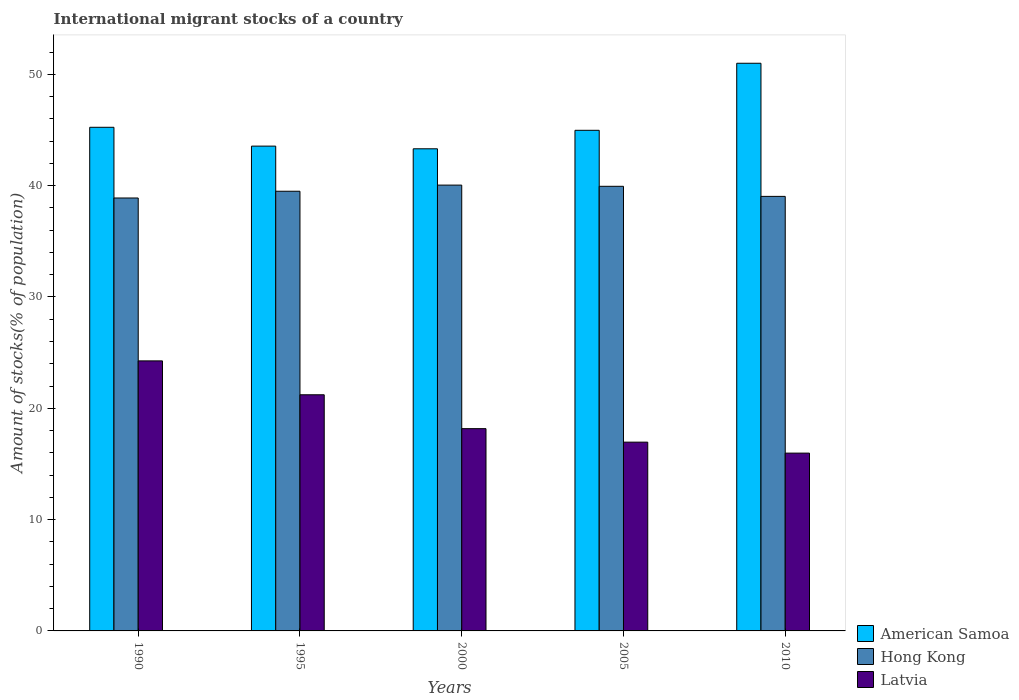How many groups of bars are there?
Provide a succinct answer. 5. Are the number of bars on each tick of the X-axis equal?
Your response must be concise. Yes. How many bars are there on the 1st tick from the left?
Your answer should be very brief. 3. What is the label of the 4th group of bars from the left?
Provide a succinct answer. 2005. In how many cases, is the number of bars for a given year not equal to the number of legend labels?
Offer a very short reply. 0. What is the amount of stocks in in American Samoa in 2000?
Offer a very short reply. 43.31. Across all years, what is the maximum amount of stocks in in Hong Kong?
Give a very brief answer. 40.05. Across all years, what is the minimum amount of stocks in in Latvia?
Provide a succinct answer. 15.97. In which year was the amount of stocks in in American Samoa maximum?
Keep it short and to the point. 2010. What is the total amount of stocks in in Hong Kong in the graph?
Your answer should be very brief. 197.41. What is the difference between the amount of stocks in in American Samoa in 1990 and that in 2010?
Keep it short and to the point. -5.75. What is the difference between the amount of stocks in in Latvia in 2010 and the amount of stocks in in Hong Kong in 1995?
Your answer should be very brief. -23.52. What is the average amount of stocks in in Latvia per year?
Give a very brief answer. 19.31. In the year 1995, what is the difference between the amount of stocks in in Hong Kong and amount of stocks in in Latvia?
Your answer should be compact. 18.28. In how many years, is the amount of stocks in in Latvia greater than 44 %?
Provide a succinct answer. 0. What is the ratio of the amount of stocks in in Hong Kong in 1995 to that in 2005?
Ensure brevity in your answer.  0.99. Is the amount of stocks in in Hong Kong in 2000 less than that in 2010?
Give a very brief answer. No. Is the difference between the amount of stocks in in Hong Kong in 1990 and 2010 greater than the difference between the amount of stocks in in Latvia in 1990 and 2010?
Provide a short and direct response. No. What is the difference between the highest and the second highest amount of stocks in in Latvia?
Make the answer very short. 3.04. What is the difference between the highest and the lowest amount of stocks in in American Samoa?
Keep it short and to the point. 7.68. What does the 2nd bar from the left in 1995 represents?
Give a very brief answer. Hong Kong. What does the 1st bar from the right in 2000 represents?
Provide a succinct answer. Latvia. Are all the bars in the graph horizontal?
Your answer should be very brief. No. How many years are there in the graph?
Provide a succinct answer. 5. What is the difference between two consecutive major ticks on the Y-axis?
Your response must be concise. 10. Are the values on the major ticks of Y-axis written in scientific E-notation?
Your answer should be compact. No. Does the graph contain grids?
Your answer should be compact. No. How many legend labels are there?
Offer a terse response. 3. What is the title of the graph?
Your response must be concise. International migrant stocks of a country. What is the label or title of the X-axis?
Provide a succinct answer. Years. What is the label or title of the Y-axis?
Provide a succinct answer. Amount of stocks(% of population). What is the Amount of stocks(% of population) in American Samoa in 1990?
Make the answer very short. 45.24. What is the Amount of stocks(% of population) of Hong Kong in 1990?
Your answer should be compact. 38.89. What is the Amount of stocks(% of population) in Latvia in 1990?
Ensure brevity in your answer.  24.26. What is the Amount of stocks(% of population) in American Samoa in 1995?
Provide a short and direct response. 43.55. What is the Amount of stocks(% of population) of Hong Kong in 1995?
Offer a terse response. 39.5. What is the Amount of stocks(% of population) in Latvia in 1995?
Your response must be concise. 21.21. What is the Amount of stocks(% of population) of American Samoa in 2000?
Ensure brevity in your answer.  43.31. What is the Amount of stocks(% of population) in Hong Kong in 2000?
Provide a short and direct response. 40.05. What is the Amount of stocks(% of population) of Latvia in 2000?
Make the answer very short. 18.17. What is the Amount of stocks(% of population) in American Samoa in 2005?
Give a very brief answer. 44.97. What is the Amount of stocks(% of population) in Hong Kong in 2005?
Offer a terse response. 39.94. What is the Amount of stocks(% of population) of Latvia in 2005?
Ensure brevity in your answer.  16.96. What is the Amount of stocks(% of population) in American Samoa in 2010?
Keep it short and to the point. 50.99. What is the Amount of stocks(% of population) of Hong Kong in 2010?
Make the answer very short. 39.03. What is the Amount of stocks(% of population) of Latvia in 2010?
Provide a succinct answer. 15.97. Across all years, what is the maximum Amount of stocks(% of population) in American Samoa?
Provide a short and direct response. 50.99. Across all years, what is the maximum Amount of stocks(% of population) in Hong Kong?
Provide a succinct answer. 40.05. Across all years, what is the maximum Amount of stocks(% of population) of Latvia?
Your response must be concise. 24.26. Across all years, what is the minimum Amount of stocks(% of population) of American Samoa?
Your answer should be compact. 43.31. Across all years, what is the minimum Amount of stocks(% of population) of Hong Kong?
Your answer should be compact. 38.89. Across all years, what is the minimum Amount of stocks(% of population) in Latvia?
Keep it short and to the point. 15.97. What is the total Amount of stocks(% of population) of American Samoa in the graph?
Your answer should be very brief. 228.06. What is the total Amount of stocks(% of population) of Hong Kong in the graph?
Offer a terse response. 197.41. What is the total Amount of stocks(% of population) in Latvia in the graph?
Offer a very short reply. 96.57. What is the difference between the Amount of stocks(% of population) in American Samoa in 1990 and that in 1995?
Your answer should be compact. 1.69. What is the difference between the Amount of stocks(% of population) of Hong Kong in 1990 and that in 1995?
Ensure brevity in your answer.  -0.61. What is the difference between the Amount of stocks(% of population) of Latvia in 1990 and that in 1995?
Give a very brief answer. 3.04. What is the difference between the Amount of stocks(% of population) in American Samoa in 1990 and that in 2000?
Your answer should be very brief. 1.93. What is the difference between the Amount of stocks(% of population) of Hong Kong in 1990 and that in 2000?
Ensure brevity in your answer.  -1.16. What is the difference between the Amount of stocks(% of population) of Latvia in 1990 and that in 2000?
Your response must be concise. 6.09. What is the difference between the Amount of stocks(% of population) of American Samoa in 1990 and that in 2005?
Ensure brevity in your answer.  0.27. What is the difference between the Amount of stocks(% of population) in Hong Kong in 1990 and that in 2005?
Make the answer very short. -1.05. What is the difference between the Amount of stocks(% of population) in Latvia in 1990 and that in 2005?
Make the answer very short. 7.3. What is the difference between the Amount of stocks(% of population) in American Samoa in 1990 and that in 2010?
Keep it short and to the point. -5.75. What is the difference between the Amount of stocks(% of population) in Hong Kong in 1990 and that in 2010?
Your answer should be very brief. -0.14. What is the difference between the Amount of stocks(% of population) in Latvia in 1990 and that in 2010?
Your answer should be very brief. 8.29. What is the difference between the Amount of stocks(% of population) of American Samoa in 1995 and that in 2000?
Keep it short and to the point. 0.24. What is the difference between the Amount of stocks(% of population) of Hong Kong in 1995 and that in 2000?
Your answer should be very brief. -0.55. What is the difference between the Amount of stocks(% of population) in Latvia in 1995 and that in 2000?
Your answer should be very brief. 3.04. What is the difference between the Amount of stocks(% of population) in American Samoa in 1995 and that in 2005?
Provide a short and direct response. -1.42. What is the difference between the Amount of stocks(% of population) in Hong Kong in 1995 and that in 2005?
Your answer should be very brief. -0.44. What is the difference between the Amount of stocks(% of population) of Latvia in 1995 and that in 2005?
Offer a terse response. 4.26. What is the difference between the Amount of stocks(% of population) of American Samoa in 1995 and that in 2010?
Offer a very short reply. -7.44. What is the difference between the Amount of stocks(% of population) in Hong Kong in 1995 and that in 2010?
Ensure brevity in your answer.  0.46. What is the difference between the Amount of stocks(% of population) of Latvia in 1995 and that in 2010?
Provide a short and direct response. 5.24. What is the difference between the Amount of stocks(% of population) of American Samoa in 2000 and that in 2005?
Make the answer very short. -1.66. What is the difference between the Amount of stocks(% of population) of Hong Kong in 2000 and that in 2005?
Provide a succinct answer. 0.11. What is the difference between the Amount of stocks(% of population) of Latvia in 2000 and that in 2005?
Your response must be concise. 1.21. What is the difference between the Amount of stocks(% of population) in American Samoa in 2000 and that in 2010?
Give a very brief answer. -7.68. What is the difference between the Amount of stocks(% of population) in Hong Kong in 2000 and that in 2010?
Provide a short and direct response. 1.01. What is the difference between the Amount of stocks(% of population) of Latvia in 2000 and that in 2010?
Make the answer very short. 2.2. What is the difference between the Amount of stocks(% of population) of American Samoa in 2005 and that in 2010?
Provide a short and direct response. -6.02. What is the difference between the Amount of stocks(% of population) in Hong Kong in 2005 and that in 2010?
Offer a terse response. 0.91. What is the difference between the Amount of stocks(% of population) in American Samoa in 1990 and the Amount of stocks(% of population) in Hong Kong in 1995?
Your answer should be very brief. 5.74. What is the difference between the Amount of stocks(% of population) of American Samoa in 1990 and the Amount of stocks(% of population) of Latvia in 1995?
Offer a very short reply. 24.03. What is the difference between the Amount of stocks(% of population) in Hong Kong in 1990 and the Amount of stocks(% of population) in Latvia in 1995?
Provide a short and direct response. 17.68. What is the difference between the Amount of stocks(% of population) in American Samoa in 1990 and the Amount of stocks(% of population) in Hong Kong in 2000?
Keep it short and to the point. 5.19. What is the difference between the Amount of stocks(% of population) in American Samoa in 1990 and the Amount of stocks(% of population) in Latvia in 2000?
Give a very brief answer. 27.07. What is the difference between the Amount of stocks(% of population) of Hong Kong in 1990 and the Amount of stocks(% of population) of Latvia in 2000?
Provide a short and direct response. 20.72. What is the difference between the Amount of stocks(% of population) in American Samoa in 1990 and the Amount of stocks(% of population) in Hong Kong in 2005?
Your response must be concise. 5.3. What is the difference between the Amount of stocks(% of population) of American Samoa in 1990 and the Amount of stocks(% of population) of Latvia in 2005?
Offer a very short reply. 28.28. What is the difference between the Amount of stocks(% of population) of Hong Kong in 1990 and the Amount of stocks(% of population) of Latvia in 2005?
Offer a terse response. 21.93. What is the difference between the Amount of stocks(% of population) in American Samoa in 1990 and the Amount of stocks(% of population) in Hong Kong in 2010?
Ensure brevity in your answer.  6.21. What is the difference between the Amount of stocks(% of population) of American Samoa in 1990 and the Amount of stocks(% of population) of Latvia in 2010?
Your answer should be compact. 29.27. What is the difference between the Amount of stocks(% of population) of Hong Kong in 1990 and the Amount of stocks(% of population) of Latvia in 2010?
Keep it short and to the point. 22.92. What is the difference between the Amount of stocks(% of population) in American Samoa in 1995 and the Amount of stocks(% of population) in Hong Kong in 2000?
Provide a succinct answer. 3.5. What is the difference between the Amount of stocks(% of population) of American Samoa in 1995 and the Amount of stocks(% of population) of Latvia in 2000?
Provide a short and direct response. 25.38. What is the difference between the Amount of stocks(% of population) of Hong Kong in 1995 and the Amount of stocks(% of population) of Latvia in 2000?
Offer a terse response. 21.33. What is the difference between the Amount of stocks(% of population) in American Samoa in 1995 and the Amount of stocks(% of population) in Hong Kong in 2005?
Offer a very short reply. 3.61. What is the difference between the Amount of stocks(% of population) of American Samoa in 1995 and the Amount of stocks(% of population) of Latvia in 2005?
Ensure brevity in your answer.  26.59. What is the difference between the Amount of stocks(% of population) in Hong Kong in 1995 and the Amount of stocks(% of population) in Latvia in 2005?
Ensure brevity in your answer.  22.54. What is the difference between the Amount of stocks(% of population) in American Samoa in 1995 and the Amount of stocks(% of population) in Hong Kong in 2010?
Offer a very short reply. 4.52. What is the difference between the Amount of stocks(% of population) in American Samoa in 1995 and the Amount of stocks(% of population) in Latvia in 2010?
Your response must be concise. 27.58. What is the difference between the Amount of stocks(% of population) in Hong Kong in 1995 and the Amount of stocks(% of population) in Latvia in 2010?
Offer a terse response. 23.52. What is the difference between the Amount of stocks(% of population) in American Samoa in 2000 and the Amount of stocks(% of population) in Hong Kong in 2005?
Keep it short and to the point. 3.37. What is the difference between the Amount of stocks(% of population) in American Samoa in 2000 and the Amount of stocks(% of population) in Latvia in 2005?
Your response must be concise. 26.35. What is the difference between the Amount of stocks(% of population) in Hong Kong in 2000 and the Amount of stocks(% of population) in Latvia in 2005?
Your response must be concise. 23.09. What is the difference between the Amount of stocks(% of population) in American Samoa in 2000 and the Amount of stocks(% of population) in Hong Kong in 2010?
Ensure brevity in your answer.  4.28. What is the difference between the Amount of stocks(% of population) of American Samoa in 2000 and the Amount of stocks(% of population) of Latvia in 2010?
Your answer should be compact. 27.34. What is the difference between the Amount of stocks(% of population) of Hong Kong in 2000 and the Amount of stocks(% of population) of Latvia in 2010?
Offer a very short reply. 24.07. What is the difference between the Amount of stocks(% of population) of American Samoa in 2005 and the Amount of stocks(% of population) of Hong Kong in 2010?
Make the answer very short. 5.94. What is the difference between the Amount of stocks(% of population) of American Samoa in 2005 and the Amount of stocks(% of population) of Latvia in 2010?
Your answer should be compact. 29. What is the difference between the Amount of stocks(% of population) of Hong Kong in 2005 and the Amount of stocks(% of population) of Latvia in 2010?
Provide a short and direct response. 23.97. What is the average Amount of stocks(% of population) in American Samoa per year?
Keep it short and to the point. 45.61. What is the average Amount of stocks(% of population) in Hong Kong per year?
Offer a very short reply. 39.48. What is the average Amount of stocks(% of population) of Latvia per year?
Keep it short and to the point. 19.31. In the year 1990, what is the difference between the Amount of stocks(% of population) of American Samoa and Amount of stocks(% of population) of Hong Kong?
Offer a terse response. 6.35. In the year 1990, what is the difference between the Amount of stocks(% of population) of American Samoa and Amount of stocks(% of population) of Latvia?
Keep it short and to the point. 20.98. In the year 1990, what is the difference between the Amount of stocks(% of population) in Hong Kong and Amount of stocks(% of population) in Latvia?
Your response must be concise. 14.63. In the year 1995, what is the difference between the Amount of stocks(% of population) of American Samoa and Amount of stocks(% of population) of Hong Kong?
Your answer should be very brief. 4.05. In the year 1995, what is the difference between the Amount of stocks(% of population) in American Samoa and Amount of stocks(% of population) in Latvia?
Keep it short and to the point. 22.34. In the year 1995, what is the difference between the Amount of stocks(% of population) of Hong Kong and Amount of stocks(% of population) of Latvia?
Your answer should be very brief. 18.28. In the year 2000, what is the difference between the Amount of stocks(% of population) of American Samoa and Amount of stocks(% of population) of Hong Kong?
Your response must be concise. 3.26. In the year 2000, what is the difference between the Amount of stocks(% of population) in American Samoa and Amount of stocks(% of population) in Latvia?
Provide a succinct answer. 25.14. In the year 2000, what is the difference between the Amount of stocks(% of population) in Hong Kong and Amount of stocks(% of population) in Latvia?
Ensure brevity in your answer.  21.88. In the year 2005, what is the difference between the Amount of stocks(% of population) in American Samoa and Amount of stocks(% of population) in Hong Kong?
Make the answer very short. 5.03. In the year 2005, what is the difference between the Amount of stocks(% of population) in American Samoa and Amount of stocks(% of population) in Latvia?
Your response must be concise. 28.01. In the year 2005, what is the difference between the Amount of stocks(% of population) of Hong Kong and Amount of stocks(% of population) of Latvia?
Provide a succinct answer. 22.98. In the year 2010, what is the difference between the Amount of stocks(% of population) of American Samoa and Amount of stocks(% of population) of Hong Kong?
Ensure brevity in your answer.  11.96. In the year 2010, what is the difference between the Amount of stocks(% of population) of American Samoa and Amount of stocks(% of population) of Latvia?
Ensure brevity in your answer.  35.02. In the year 2010, what is the difference between the Amount of stocks(% of population) of Hong Kong and Amount of stocks(% of population) of Latvia?
Your answer should be very brief. 23.06. What is the ratio of the Amount of stocks(% of population) in American Samoa in 1990 to that in 1995?
Provide a short and direct response. 1.04. What is the ratio of the Amount of stocks(% of population) in Hong Kong in 1990 to that in 1995?
Your answer should be compact. 0.98. What is the ratio of the Amount of stocks(% of population) of Latvia in 1990 to that in 1995?
Offer a very short reply. 1.14. What is the ratio of the Amount of stocks(% of population) of American Samoa in 1990 to that in 2000?
Keep it short and to the point. 1.04. What is the ratio of the Amount of stocks(% of population) in Hong Kong in 1990 to that in 2000?
Your answer should be compact. 0.97. What is the ratio of the Amount of stocks(% of population) of Latvia in 1990 to that in 2000?
Your answer should be compact. 1.33. What is the ratio of the Amount of stocks(% of population) of Hong Kong in 1990 to that in 2005?
Provide a succinct answer. 0.97. What is the ratio of the Amount of stocks(% of population) of Latvia in 1990 to that in 2005?
Your answer should be very brief. 1.43. What is the ratio of the Amount of stocks(% of population) of American Samoa in 1990 to that in 2010?
Your answer should be very brief. 0.89. What is the ratio of the Amount of stocks(% of population) in Latvia in 1990 to that in 2010?
Provide a short and direct response. 1.52. What is the ratio of the Amount of stocks(% of population) of American Samoa in 1995 to that in 2000?
Provide a succinct answer. 1.01. What is the ratio of the Amount of stocks(% of population) in Hong Kong in 1995 to that in 2000?
Offer a very short reply. 0.99. What is the ratio of the Amount of stocks(% of population) of Latvia in 1995 to that in 2000?
Your answer should be very brief. 1.17. What is the ratio of the Amount of stocks(% of population) of American Samoa in 1995 to that in 2005?
Your response must be concise. 0.97. What is the ratio of the Amount of stocks(% of population) in Hong Kong in 1995 to that in 2005?
Make the answer very short. 0.99. What is the ratio of the Amount of stocks(% of population) in Latvia in 1995 to that in 2005?
Give a very brief answer. 1.25. What is the ratio of the Amount of stocks(% of population) of American Samoa in 1995 to that in 2010?
Keep it short and to the point. 0.85. What is the ratio of the Amount of stocks(% of population) in Hong Kong in 1995 to that in 2010?
Keep it short and to the point. 1.01. What is the ratio of the Amount of stocks(% of population) in Latvia in 1995 to that in 2010?
Your answer should be very brief. 1.33. What is the ratio of the Amount of stocks(% of population) in American Samoa in 2000 to that in 2005?
Keep it short and to the point. 0.96. What is the ratio of the Amount of stocks(% of population) in Latvia in 2000 to that in 2005?
Your response must be concise. 1.07. What is the ratio of the Amount of stocks(% of population) in American Samoa in 2000 to that in 2010?
Provide a succinct answer. 0.85. What is the ratio of the Amount of stocks(% of population) of Hong Kong in 2000 to that in 2010?
Make the answer very short. 1.03. What is the ratio of the Amount of stocks(% of population) in Latvia in 2000 to that in 2010?
Your answer should be very brief. 1.14. What is the ratio of the Amount of stocks(% of population) in American Samoa in 2005 to that in 2010?
Your answer should be compact. 0.88. What is the ratio of the Amount of stocks(% of population) of Hong Kong in 2005 to that in 2010?
Your response must be concise. 1.02. What is the ratio of the Amount of stocks(% of population) of Latvia in 2005 to that in 2010?
Provide a succinct answer. 1.06. What is the difference between the highest and the second highest Amount of stocks(% of population) in American Samoa?
Offer a terse response. 5.75. What is the difference between the highest and the second highest Amount of stocks(% of population) in Hong Kong?
Your answer should be very brief. 0.11. What is the difference between the highest and the second highest Amount of stocks(% of population) of Latvia?
Give a very brief answer. 3.04. What is the difference between the highest and the lowest Amount of stocks(% of population) in American Samoa?
Give a very brief answer. 7.68. What is the difference between the highest and the lowest Amount of stocks(% of population) of Hong Kong?
Provide a short and direct response. 1.16. What is the difference between the highest and the lowest Amount of stocks(% of population) of Latvia?
Provide a short and direct response. 8.29. 